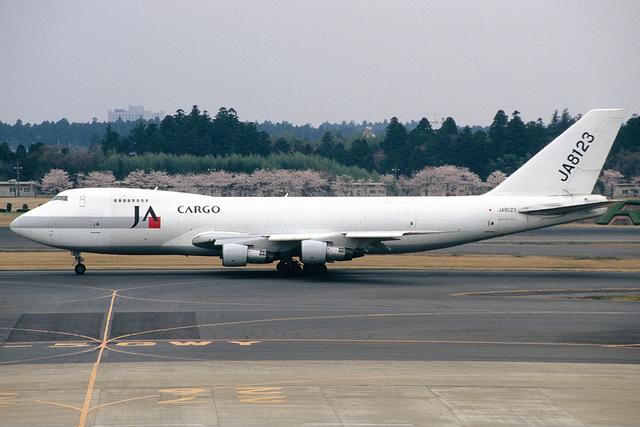Is this a passenger plane?
Write a very short answer. No. What is the airplane number on the tail?
Concise answer only. Ja8123. Are there windows on the plane?
Answer briefly. Yes. Is the airplane in the air?
Concise answer only. No. How many windows are on the airplane?
Be succinct. 10. Is this a commercial passenger plane?
Short answer required. Yes. How many planes are in the picture?
Quick response, please. 1. What is written on the tail of the plane?
Be succinct. Ja8123. Are there any buildings in the background?
Give a very brief answer. Yes. 